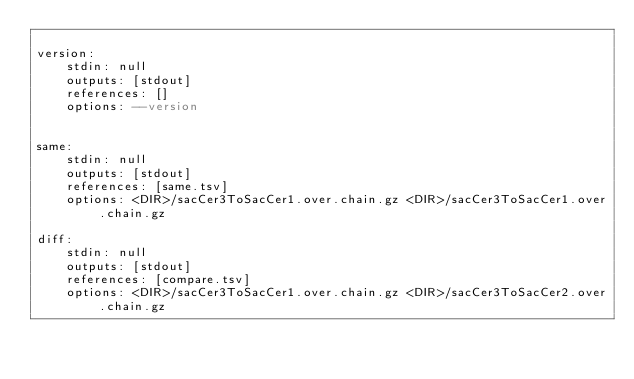Convert code to text. <code><loc_0><loc_0><loc_500><loc_500><_YAML_>
version:
    stdin: null
    outputs: [stdout]
    references: []
    options: --version


same:
    stdin: null
    outputs: [stdout]
    references: [same.tsv]
    options: <DIR>/sacCer3ToSacCer1.over.chain.gz <DIR>/sacCer3ToSacCer1.over.chain.gz

diff:
    stdin: null
    outputs: [stdout]
    references: [compare.tsv]
    options: <DIR>/sacCer3ToSacCer1.over.chain.gz <DIR>/sacCer3ToSacCer2.over.chain.gz  
</code> 